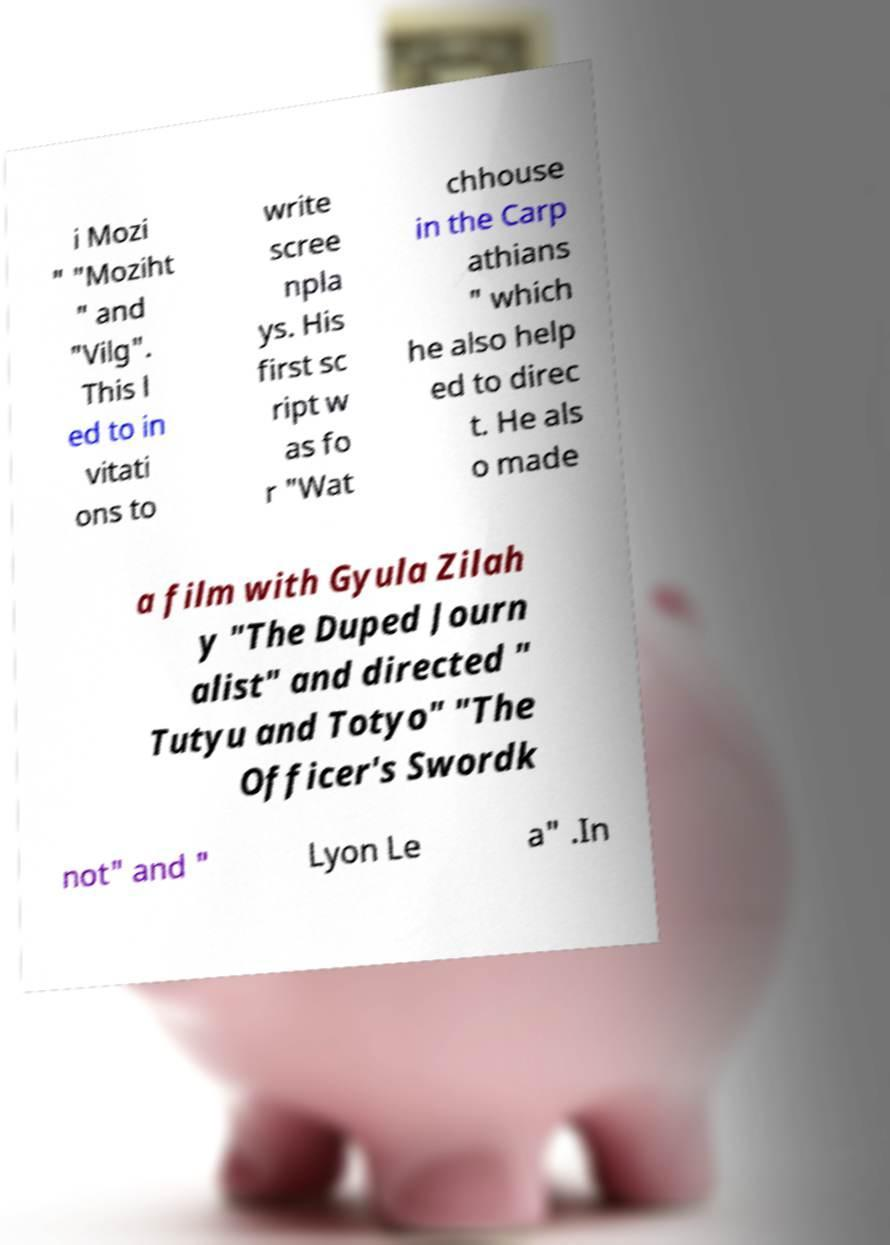Could you assist in decoding the text presented in this image and type it out clearly? i Mozi " "Moziht " and "Vilg". This l ed to in vitati ons to write scree npla ys. His first sc ript w as fo r "Wat chhouse in the Carp athians " which he also help ed to direc t. He als o made a film with Gyula Zilah y "The Duped Journ alist" and directed " Tutyu and Totyo" "The Officer's Swordk not" and " Lyon Le a" .In 